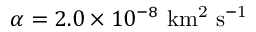<formula> <loc_0><loc_0><loc_500><loc_500>\alpha = 2 . 0 \times 1 0 ^ { - 8 } \ k m ^ { 2 } \ s ^ { - 1 }</formula> 